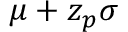<formula> <loc_0><loc_0><loc_500><loc_500>\mu + z _ { p } \sigma</formula> 